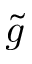<formula> <loc_0><loc_0><loc_500><loc_500>\widetilde { g }</formula> 